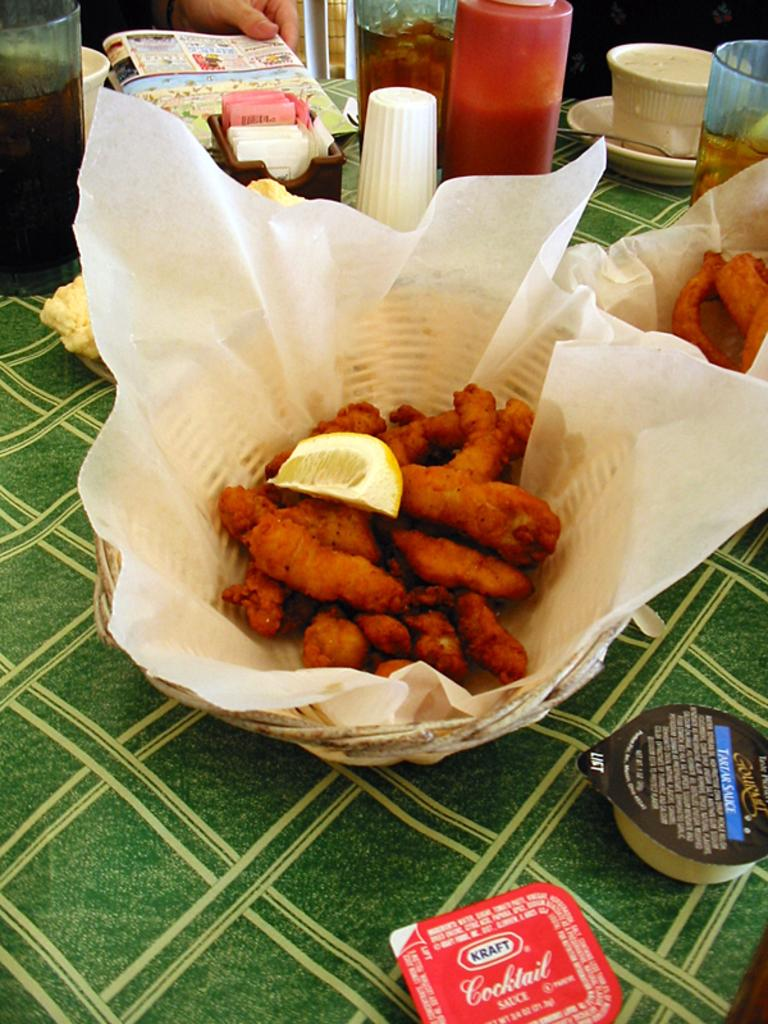<image>
Give a short and clear explanation of the subsequent image. A basket of fried food with Kraft cocktail sauce and tartar sauce packets on the table nearby. 